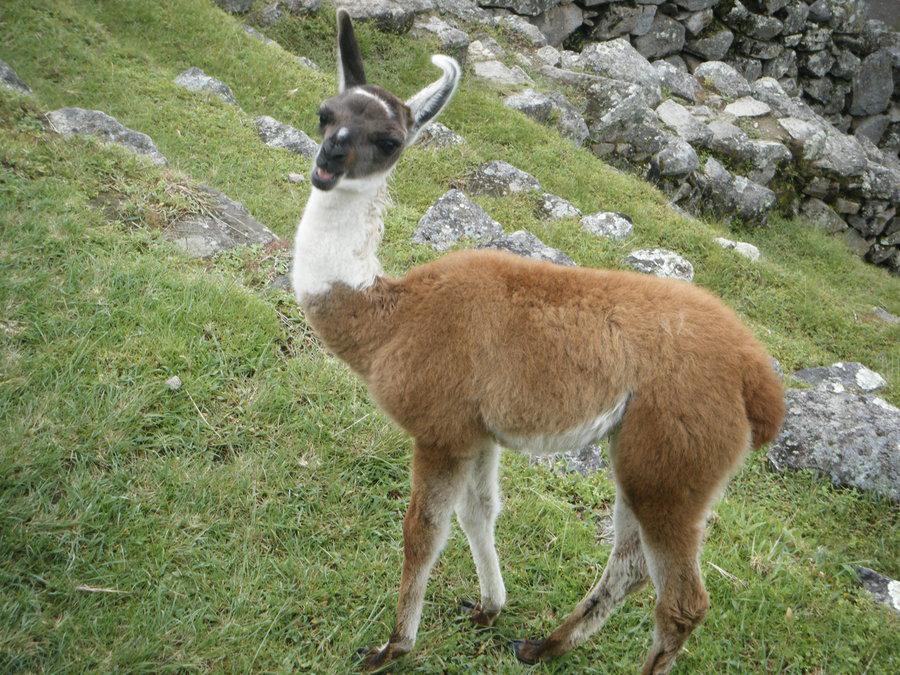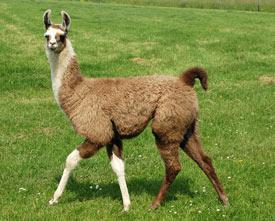The first image is the image on the left, the second image is the image on the right. Given the left and right images, does the statement "The left and right image contains the same number of llamas." hold true? Answer yes or no. Yes. The first image is the image on the left, the second image is the image on the right. For the images displayed, is the sentence "There are exactly two llamas in total." factually correct? Answer yes or no. Yes. 